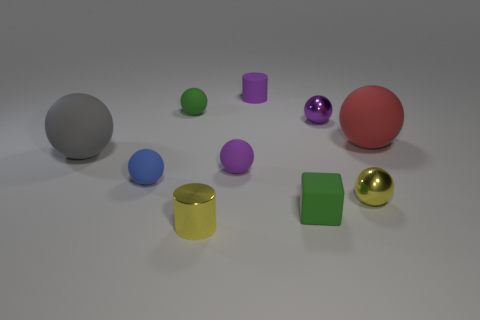Subtract all tiny blue matte spheres. How many spheres are left? 6 Subtract all blue spheres. How many spheres are left? 6 Subtract all green cylinders. How many purple balls are left? 2 Subtract all cylinders. How many objects are left? 8 Add 2 large things. How many large things are left? 4 Add 1 small green metal cubes. How many small green metal cubes exist? 1 Subtract 1 yellow cylinders. How many objects are left? 9 Subtract all purple balls. Subtract all green blocks. How many balls are left? 5 Subtract all small purple rubber cylinders. Subtract all red spheres. How many objects are left? 8 